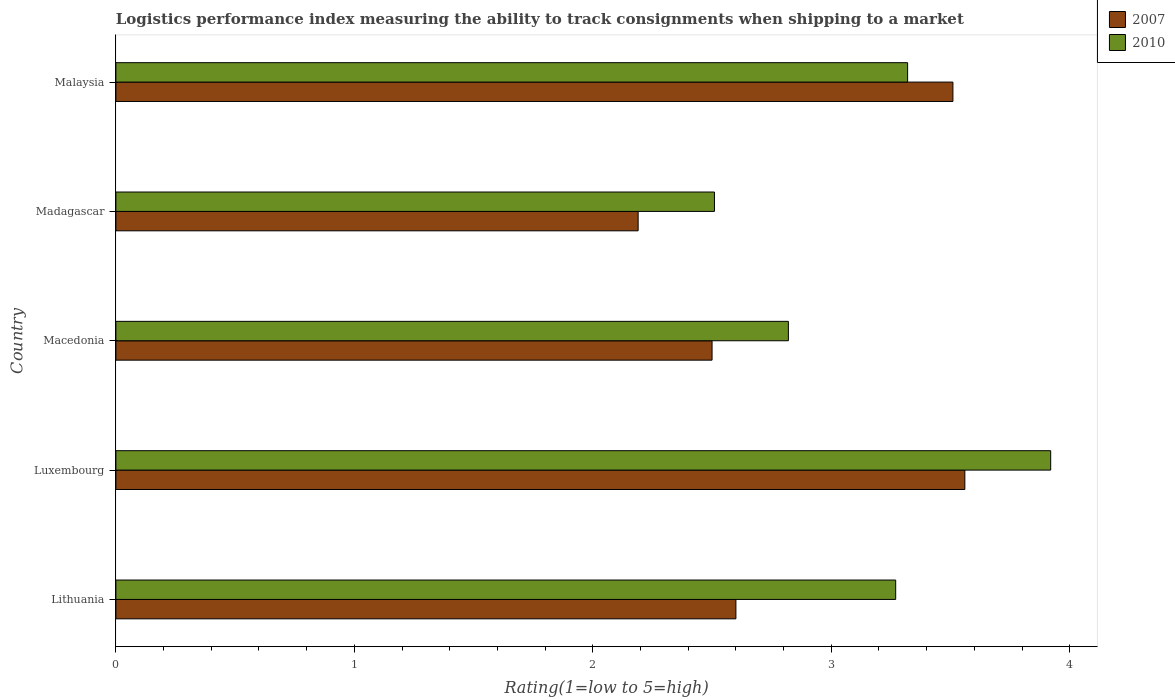How many different coloured bars are there?
Give a very brief answer. 2. How many groups of bars are there?
Provide a succinct answer. 5. Are the number of bars on each tick of the Y-axis equal?
Your answer should be very brief. Yes. How many bars are there on the 5th tick from the top?
Ensure brevity in your answer.  2. How many bars are there on the 2nd tick from the bottom?
Give a very brief answer. 2. What is the label of the 3rd group of bars from the top?
Offer a terse response. Macedonia. In how many cases, is the number of bars for a given country not equal to the number of legend labels?
Provide a short and direct response. 0. What is the Logistic performance index in 2007 in Lithuania?
Make the answer very short. 2.6. Across all countries, what is the maximum Logistic performance index in 2010?
Keep it short and to the point. 3.92. Across all countries, what is the minimum Logistic performance index in 2007?
Offer a very short reply. 2.19. In which country was the Logistic performance index in 2010 maximum?
Ensure brevity in your answer.  Luxembourg. In which country was the Logistic performance index in 2010 minimum?
Offer a very short reply. Madagascar. What is the total Logistic performance index in 2007 in the graph?
Offer a very short reply. 14.36. What is the difference between the Logistic performance index in 2010 in Luxembourg and that in Malaysia?
Your response must be concise. 0.6. What is the difference between the Logistic performance index in 2007 in Macedonia and the Logistic performance index in 2010 in Malaysia?
Your answer should be compact. -0.82. What is the average Logistic performance index in 2007 per country?
Your answer should be compact. 2.87. What is the difference between the Logistic performance index in 2010 and Logistic performance index in 2007 in Madagascar?
Offer a terse response. 0.32. What is the ratio of the Logistic performance index in 2010 in Macedonia to that in Malaysia?
Make the answer very short. 0.85. Is the Logistic performance index in 2010 in Lithuania less than that in Madagascar?
Ensure brevity in your answer.  No. What is the difference between the highest and the second highest Logistic performance index in 2007?
Offer a very short reply. 0.05. What is the difference between the highest and the lowest Logistic performance index in 2007?
Keep it short and to the point. 1.37. In how many countries, is the Logistic performance index in 2010 greater than the average Logistic performance index in 2010 taken over all countries?
Give a very brief answer. 3. What does the 2nd bar from the bottom in Madagascar represents?
Your answer should be compact. 2010. How many bars are there?
Offer a very short reply. 10. How many countries are there in the graph?
Your answer should be compact. 5. What is the difference between two consecutive major ticks on the X-axis?
Give a very brief answer. 1. Does the graph contain any zero values?
Provide a succinct answer. No. Does the graph contain grids?
Give a very brief answer. No. How are the legend labels stacked?
Provide a succinct answer. Vertical. What is the title of the graph?
Make the answer very short. Logistics performance index measuring the ability to track consignments when shipping to a market. What is the label or title of the X-axis?
Your answer should be very brief. Rating(1=low to 5=high). What is the Rating(1=low to 5=high) of 2007 in Lithuania?
Provide a short and direct response. 2.6. What is the Rating(1=low to 5=high) in 2010 in Lithuania?
Provide a short and direct response. 3.27. What is the Rating(1=low to 5=high) in 2007 in Luxembourg?
Ensure brevity in your answer.  3.56. What is the Rating(1=low to 5=high) of 2010 in Luxembourg?
Your answer should be very brief. 3.92. What is the Rating(1=low to 5=high) in 2007 in Macedonia?
Your answer should be very brief. 2.5. What is the Rating(1=low to 5=high) of 2010 in Macedonia?
Offer a terse response. 2.82. What is the Rating(1=low to 5=high) of 2007 in Madagascar?
Your response must be concise. 2.19. What is the Rating(1=low to 5=high) of 2010 in Madagascar?
Offer a very short reply. 2.51. What is the Rating(1=low to 5=high) of 2007 in Malaysia?
Your response must be concise. 3.51. What is the Rating(1=low to 5=high) of 2010 in Malaysia?
Offer a terse response. 3.32. Across all countries, what is the maximum Rating(1=low to 5=high) in 2007?
Your response must be concise. 3.56. Across all countries, what is the maximum Rating(1=low to 5=high) of 2010?
Your answer should be compact. 3.92. Across all countries, what is the minimum Rating(1=low to 5=high) in 2007?
Your answer should be compact. 2.19. Across all countries, what is the minimum Rating(1=low to 5=high) of 2010?
Your response must be concise. 2.51. What is the total Rating(1=low to 5=high) in 2007 in the graph?
Ensure brevity in your answer.  14.36. What is the total Rating(1=low to 5=high) of 2010 in the graph?
Ensure brevity in your answer.  15.84. What is the difference between the Rating(1=low to 5=high) in 2007 in Lithuania and that in Luxembourg?
Your response must be concise. -0.96. What is the difference between the Rating(1=low to 5=high) of 2010 in Lithuania and that in Luxembourg?
Your answer should be compact. -0.65. What is the difference between the Rating(1=low to 5=high) of 2007 in Lithuania and that in Macedonia?
Make the answer very short. 0.1. What is the difference between the Rating(1=low to 5=high) in 2010 in Lithuania and that in Macedonia?
Provide a short and direct response. 0.45. What is the difference between the Rating(1=low to 5=high) of 2007 in Lithuania and that in Madagascar?
Provide a succinct answer. 0.41. What is the difference between the Rating(1=low to 5=high) in 2010 in Lithuania and that in Madagascar?
Your answer should be compact. 0.76. What is the difference between the Rating(1=low to 5=high) of 2007 in Lithuania and that in Malaysia?
Ensure brevity in your answer.  -0.91. What is the difference between the Rating(1=low to 5=high) of 2007 in Luxembourg and that in Macedonia?
Your answer should be very brief. 1.06. What is the difference between the Rating(1=low to 5=high) in 2007 in Luxembourg and that in Madagascar?
Give a very brief answer. 1.37. What is the difference between the Rating(1=low to 5=high) of 2010 in Luxembourg and that in Madagascar?
Provide a succinct answer. 1.41. What is the difference between the Rating(1=low to 5=high) in 2007 in Luxembourg and that in Malaysia?
Keep it short and to the point. 0.05. What is the difference between the Rating(1=low to 5=high) in 2010 in Luxembourg and that in Malaysia?
Your answer should be compact. 0.6. What is the difference between the Rating(1=low to 5=high) in 2007 in Macedonia and that in Madagascar?
Make the answer very short. 0.31. What is the difference between the Rating(1=low to 5=high) in 2010 in Macedonia and that in Madagascar?
Offer a terse response. 0.31. What is the difference between the Rating(1=low to 5=high) in 2007 in Macedonia and that in Malaysia?
Ensure brevity in your answer.  -1.01. What is the difference between the Rating(1=low to 5=high) of 2007 in Madagascar and that in Malaysia?
Give a very brief answer. -1.32. What is the difference between the Rating(1=low to 5=high) in 2010 in Madagascar and that in Malaysia?
Ensure brevity in your answer.  -0.81. What is the difference between the Rating(1=low to 5=high) of 2007 in Lithuania and the Rating(1=low to 5=high) of 2010 in Luxembourg?
Keep it short and to the point. -1.32. What is the difference between the Rating(1=low to 5=high) in 2007 in Lithuania and the Rating(1=low to 5=high) in 2010 in Macedonia?
Offer a very short reply. -0.22. What is the difference between the Rating(1=low to 5=high) of 2007 in Lithuania and the Rating(1=low to 5=high) of 2010 in Madagascar?
Your answer should be compact. 0.09. What is the difference between the Rating(1=low to 5=high) of 2007 in Lithuania and the Rating(1=low to 5=high) of 2010 in Malaysia?
Provide a succinct answer. -0.72. What is the difference between the Rating(1=low to 5=high) of 2007 in Luxembourg and the Rating(1=low to 5=high) of 2010 in Macedonia?
Offer a terse response. 0.74. What is the difference between the Rating(1=low to 5=high) of 2007 in Luxembourg and the Rating(1=low to 5=high) of 2010 in Malaysia?
Provide a succinct answer. 0.24. What is the difference between the Rating(1=low to 5=high) in 2007 in Macedonia and the Rating(1=low to 5=high) in 2010 in Madagascar?
Ensure brevity in your answer.  -0.01. What is the difference between the Rating(1=low to 5=high) in 2007 in Macedonia and the Rating(1=low to 5=high) in 2010 in Malaysia?
Ensure brevity in your answer.  -0.82. What is the difference between the Rating(1=low to 5=high) of 2007 in Madagascar and the Rating(1=low to 5=high) of 2010 in Malaysia?
Give a very brief answer. -1.13. What is the average Rating(1=low to 5=high) of 2007 per country?
Your answer should be compact. 2.87. What is the average Rating(1=low to 5=high) in 2010 per country?
Ensure brevity in your answer.  3.17. What is the difference between the Rating(1=low to 5=high) of 2007 and Rating(1=low to 5=high) of 2010 in Lithuania?
Provide a short and direct response. -0.67. What is the difference between the Rating(1=low to 5=high) of 2007 and Rating(1=low to 5=high) of 2010 in Luxembourg?
Offer a terse response. -0.36. What is the difference between the Rating(1=low to 5=high) of 2007 and Rating(1=low to 5=high) of 2010 in Macedonia?
Your answer should be compact. -0.32. What is the difference between the Rating(1=low to 5=high) of 2007 and Rating(1=low to 5=high) of 2010 in Madagascar?
Give a very brief answer. -0.32. What is the difference between the Rating(1=low to 5=high) in 2007 and Rating(1=low to 5=high) in 2010 in Malaysia?
Offer a terse response. 0.19. What is the ratio of the Rating(1=low to 5=high) in 2007 in Lithuania to that in Luxembourg?
Offer a terse response. 0.73. What is the ratio of the Rating(1=low to 5=high) of 2010 in Lithuania to that in Luxembourg?
Make the answer very short. 0.83. What is the ratio of the Rating(1=low to 5=high) of 2007 in Lithuania to that in Macedonia?
Your answer should be compact. 1.04. What is the ratio of the Rating(1=low to 5=high) in 2010 in Lithuania to that in Macedonia?
Ensure brevity in your answer.  1.16. What is the ratio of the Rating(1=low to 5=high) of 2007 in Lithuania to that in Madagascar?
Your response must be concise. 1.19. What is the ratio of the Rating(1=low to 5=high) of 2010 in Lithuania to that in Madagascar?
Offer a very short reply. 1.3. What is the ratio of the Rating(1=low to 5=high) of 2007 in Lithuania to that in Malaysia?
Make the answer very short. 0.74. What is the ratio of the Rating(1=low to 5=high) of 2010 in Lithuania to that in Malaysia?
Offer a very short reply. 0.98. What is the ratio of the Rating(1=low to 5=high) of 2007 in Luxembourg to that in Macedonia?
Your response must be concise. 1.42. What is the ratio of the Rating(1=low to 5=high) in 2010 in Luxembourg to that in Macedonia?
Offer a terse response. 1.39. What is the ratio of the Rating(1=low to 5=high) in 2007 in Luxembourg to that in Madagascar?
Keep it short and to the point. 1.63. What is the ratio of the Rating(1=low to 5=high) of 2010 in Luxembourg to that in Madagascar?
Make the answer very short. 1.56. What is the ratio of the Rating(1=low to 5=high) in 2007 in Luxembourg to that in Malaysia?
Your answer should be compact. 1.01. What is the ratio of the Rating(1=low to 5=high) of 2010 in Luxembourg to that in Malaysia?
Provide a succinct answer. 1.18. What is the ratio of the Rating(1=low to 5=high) of 2007 in Macedonia to that in Madagascar?
Make the answer very short. 1.14. What is the ratio of the Rating(1=low to 5=high) in 2010 in Macedonia to that in Madagascar?
Ensure brevity in your answer.  1.12. What is the ratio of the Rating(1=low to 5=high) in 2007 in Macedonia to that in Malaysia?
Your answer should be very brief. 0.71. What is the ratio of the Rating(1=low to 5=high) of 2010 in Macedonia to that in Malaysia?
Give a very brief answer. 0.85. What is the ratio of the Rating(1=low to 5=high) in 2007 in Madagascar to that in Malaysia?
Keep it short and to the point. 0.62. What is the ratio of the Rating(1=low to 5=high) in 2010 in Madagascar to that in Malaysia?
Ensure brevity in your answer.  0.76. What is the difference between the highest and the lowest Rating(1=low to 5=high) of 2007?
Give a very brief answer. 1.37. What is the difference between the highest and the lowest Rating(1=low to 5=high) of 2010?
Provide a short and direct response. 1.41. 